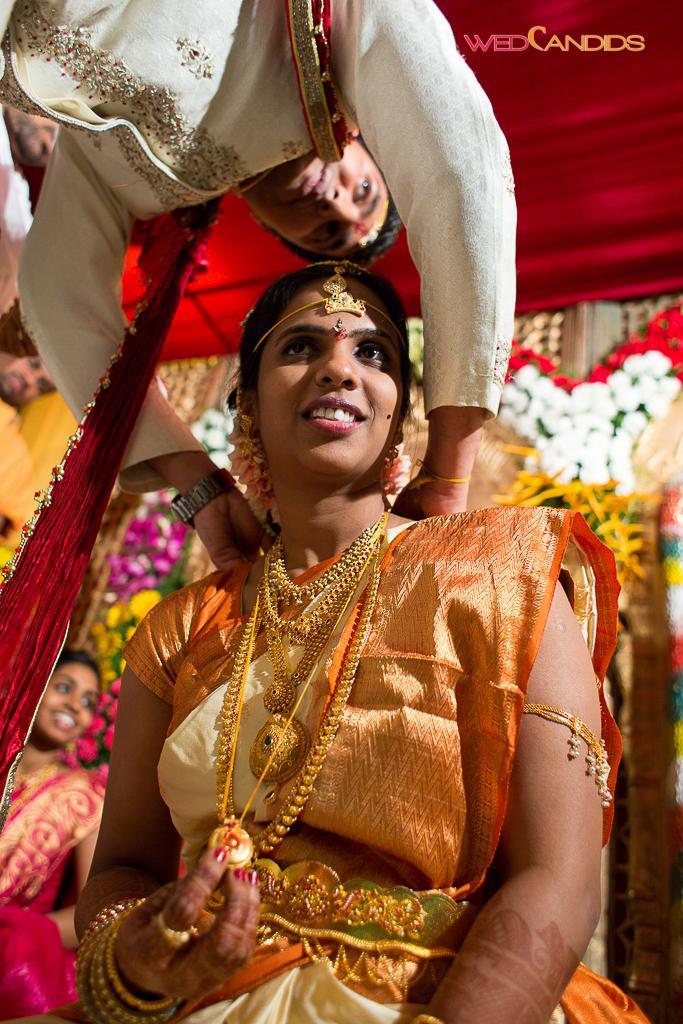In one or two sentences, can you explain what this image depicts? In this image, we can see a wedding. There are some persons wearing clothes. In the background, we can see some flowers. 